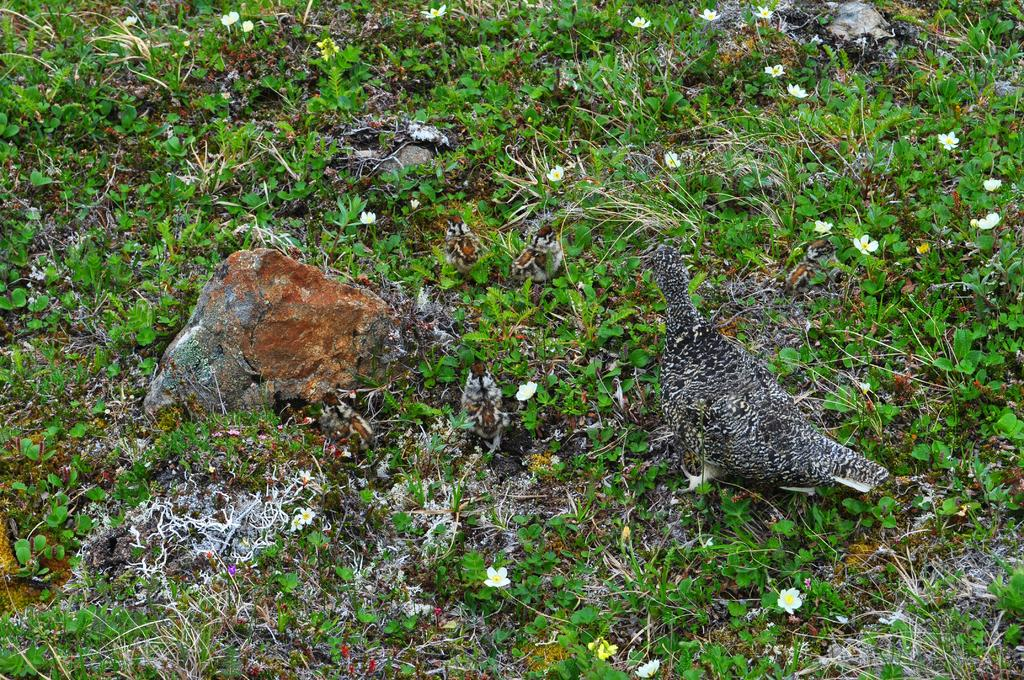What type of animal is present in the image? There is a bird in the image. What other objects can be seen in the image? There are stones and tiny plants visible in the image. What type of vegetation is present in the image? There are flowers in the image. What type of border is surrounding the bird in the image? There is no border surrounding the bird in the image. How many spiders can be seen in the image? There are no spiders present in the image. 